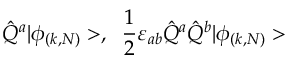<formula> <loc_0><loc_0><loc_500><loc_500>\hat { Q } ^ { a } | \phi _ { ( k , N ) } > , \, \frac { 1 } { 2 } \varepsilon _ { a b } \hat { Q } ^ { a } \hat { Q } ^ { b } | \phi _ { ( k , N ) } ></formula> 